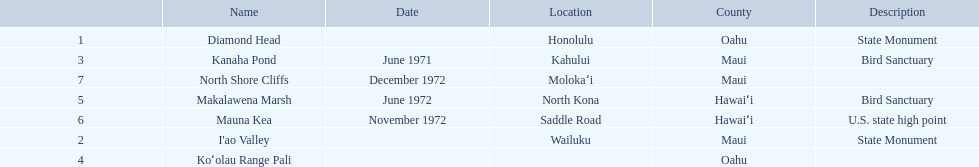Other than mauna kea, name a place in hawaii. Makalawena Marsh. I'm looking to parse the entire table for insights. Could you assist me with that? {'header': ['', 'Name', 'Date', 'Location', 'County', 'Description'], 'rows': [['1', 'Diamond Head', '', 'Honolulu', 'Oahu', 'State Monument'], ['3', 'Kanaha Pond', 'June 1971', 'Kahului', 'Maui', 'Bird Sanctuary'], ['7', 'North Shore Cliffs', 'December 1972', 'Molokaʻi', 'Maui', ''], ['5', 'Makalawena Marsh', 'June 1972', 'North Kona', 'Hawaiʻi', 'Bird Sanctuary'], ['6', 'Mauna Kea', 'November 1972', 'Saddle Road', 'Hawaiʻi', 'U.S. state high point'], ['2', "I'ao Valley", '', 'Wailuku', 'Maui', 'State Monument'], ['4', 'Koʻolau Range Pali', '', '', 'Oahu', '']]} 